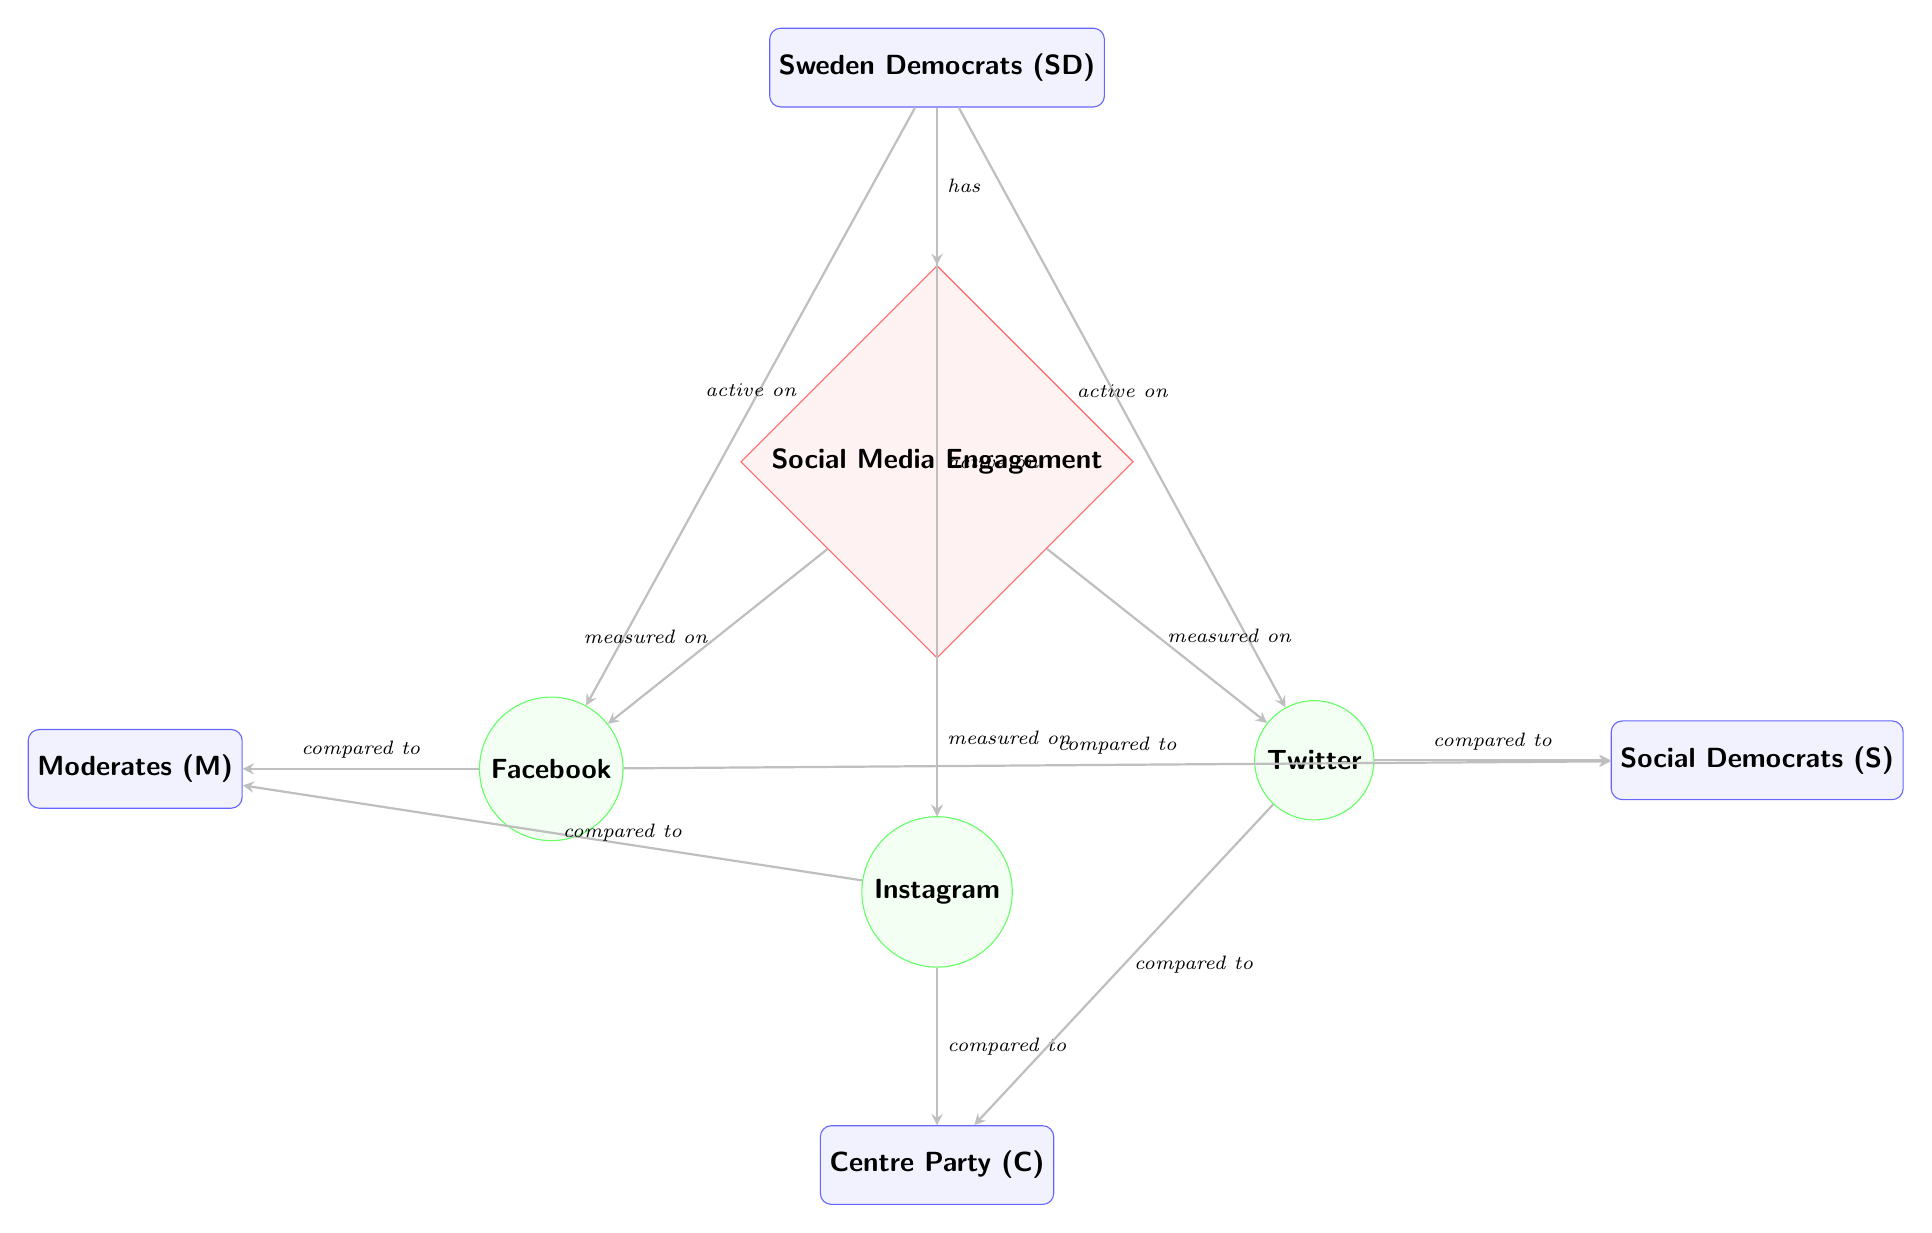What party is being analyzed for social media engagement? The main node labeled "Sweden Democrats (SD)" within the diagram indicates that the focus of the analysis is on the Sweden Democrats party.
Answer: Sweden Democrats (SD) How many social media platforms are represented in the diagram? The diagram includes three nodes labeled for social media platforms: Facebook, Instagram, and Twitter, indicating that there are three platforms represented.
Answer: 3 Which party is being compared to the Sweden Democrats on Facebook? The diagram shows an arrow bent from the Facebook node to the Moderates node, indicating that the comparison is made between the Sweden Democrats and the Moderates party on Facebook.
Answer: Moderates (M) What kind of metric is "Social Media Engagement"? In the diagram, "Social Media Engagement" is represented as a diamond-shaped node, which signifies that it is considered a metric being measured across the different platforms.
Answer: Metric How many parties are active on Instagram according to the diagram? The diagram shows arrows from the Sweden Democrats to the Instagram node and another arrow going to the Centre Party, thereby indicating that two parties are active on Instagram.
Answer: 2 Which party is compared to the Centre Party on Instagram? The diagram has an arrow that signals a comparison from the Instagram node to the Centre Party node, but there are no additional comparisons listed here indicating that it stands alone in this analysis. Thus, no party is explicitly compared in a direct manner to the Centre Party on Instagram.
Answer: None Which social media platform has the most connections in comparisons with other parties? Facebook and Twitter both show multiple connections, but in the current layout, Facebook makes comparisons with the Moderates and Social Democrats, and Twitter is only compared with the Social Democrats, rendering Facebook as the platform with the most connections.
Answer: Facebook Is the Sweden Democrats party active on Twitter? An arrow extending from the Sweden Democrats node to the Twitter platform indicates that the Sweden Democrats are indeed active on Twitter, as denoted within the diagram's layout.
Answer: Yes What type of relationship is depicted between the Sweden Democrats and Social Media Engagement? The diagram represents a direct relationship with an arrow pointing from the Sweden Democrats to the Social Media Engagement node, indicating that the Sweden Democrats "has" this engagement metric.
Answer: Has 